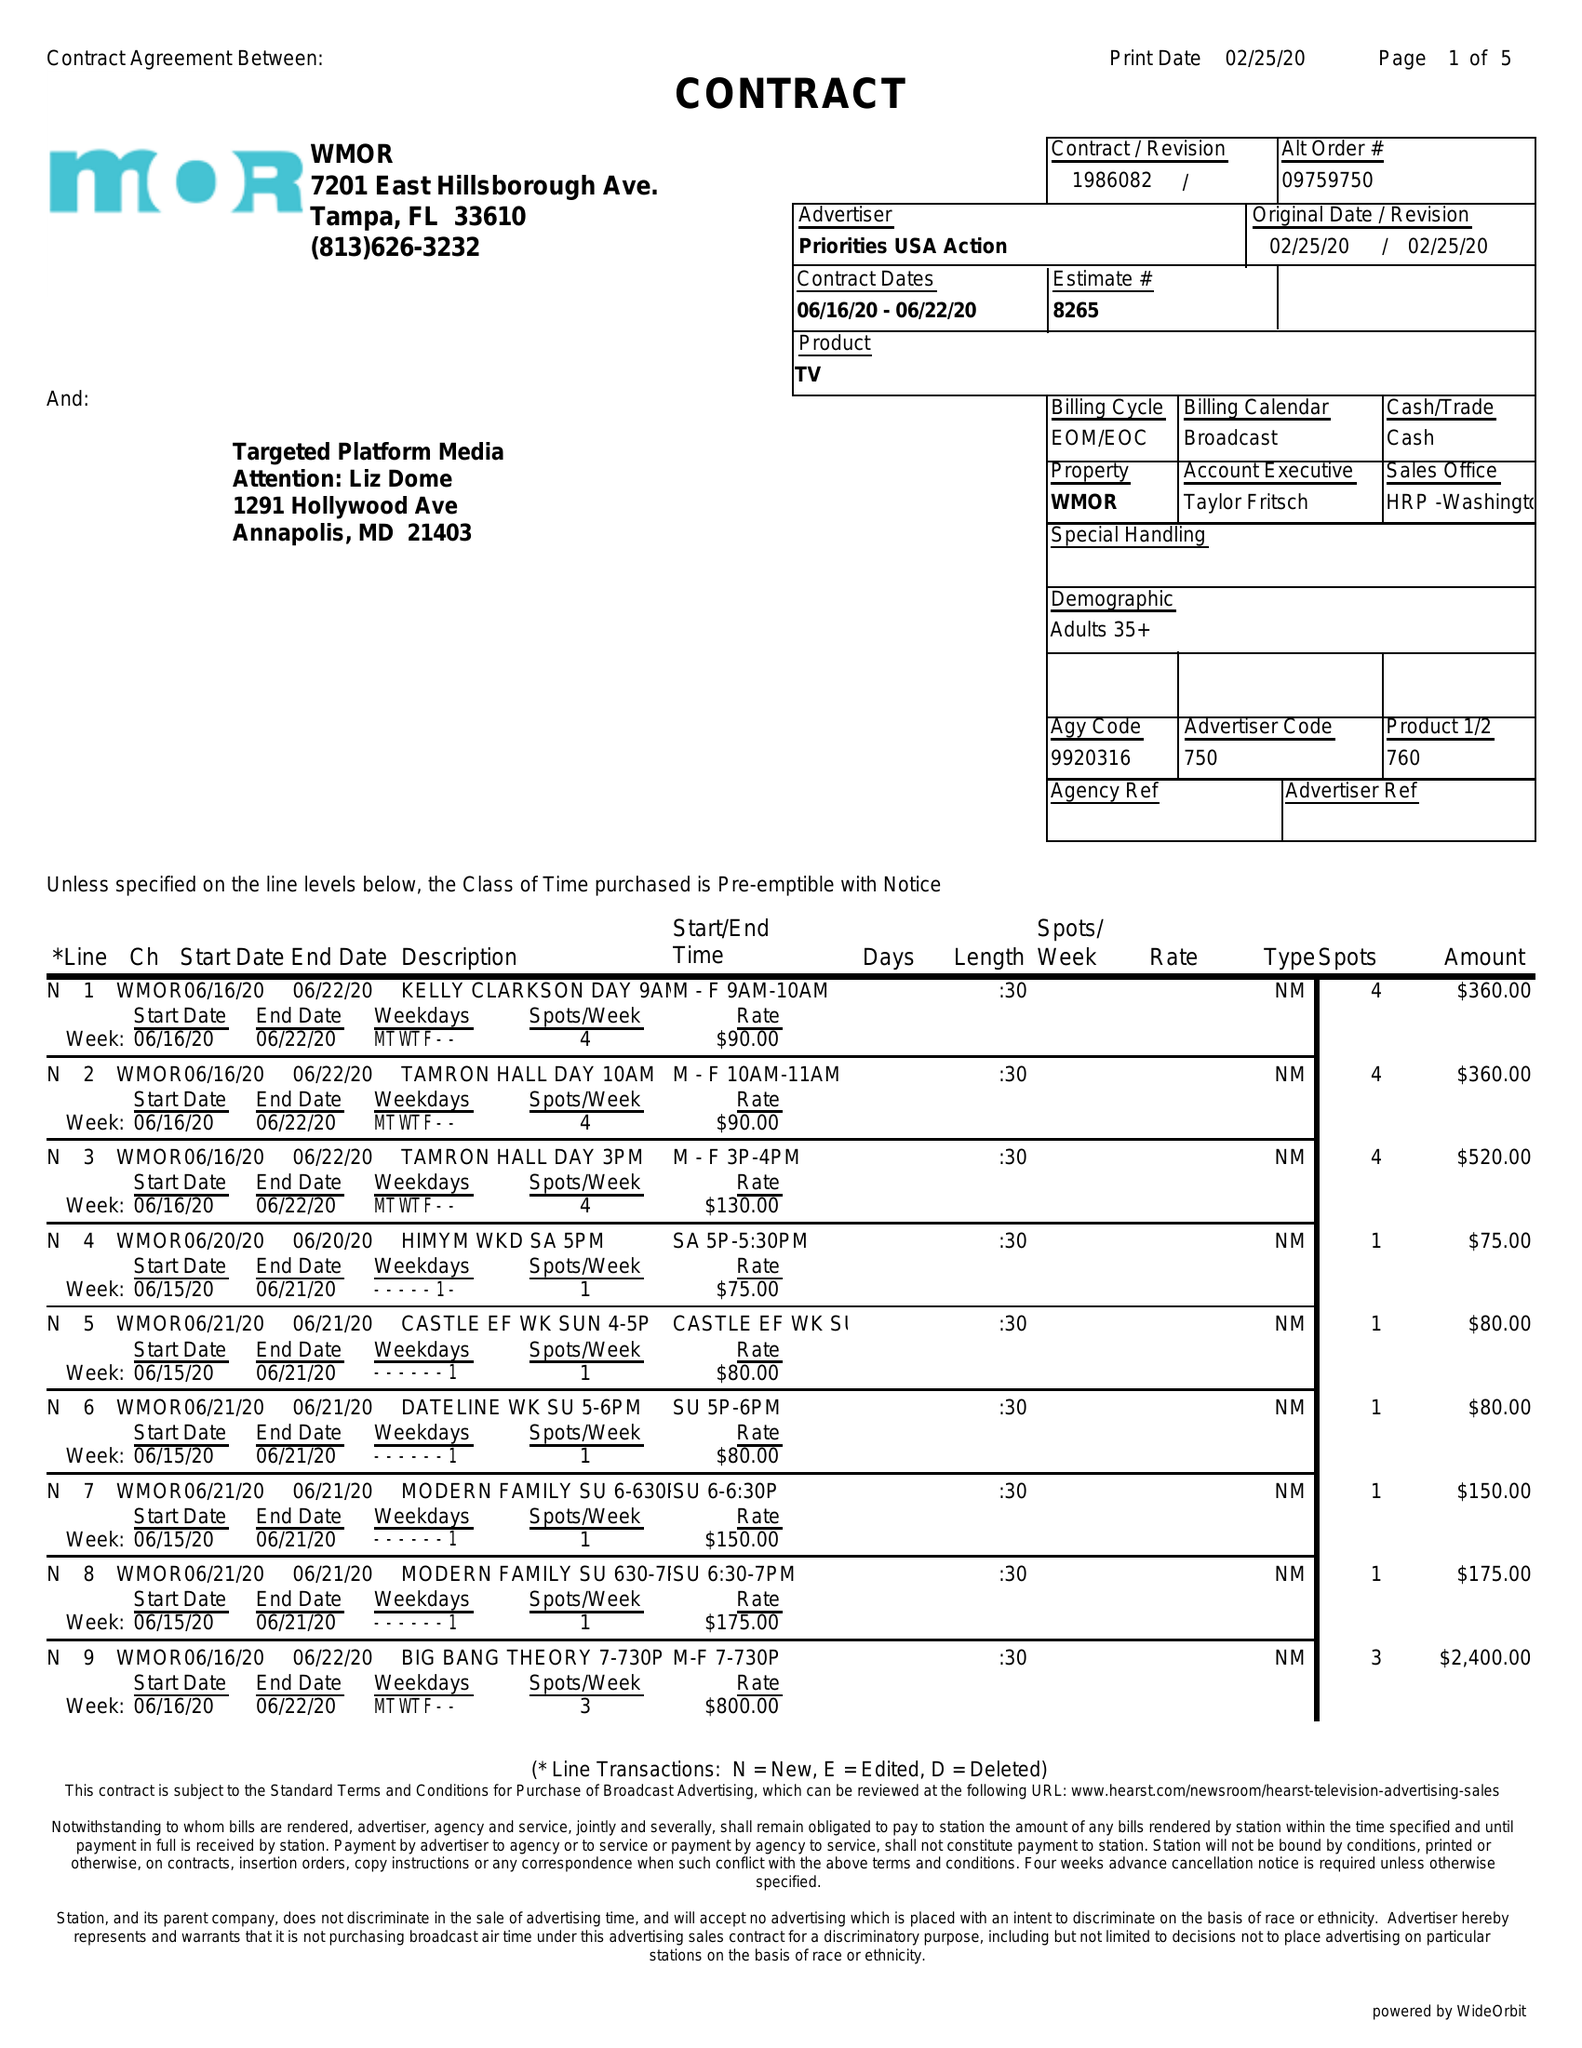What is the value for the advertiser?
Answer the question using a single word or phrase. PRIORITIES USA ACTION 